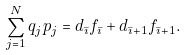<formula> <loc_0><loc_0><loc_500><loc_500>\sum _ { j = 1 } ^ { N } q _ { j } p _ { j } = d _ { \bar { \imath } } f _ { \bar { \imath } } + d _ { \bar { \imath } + 1 } f _ { \bar { \imath } + 1 } .</formula> 